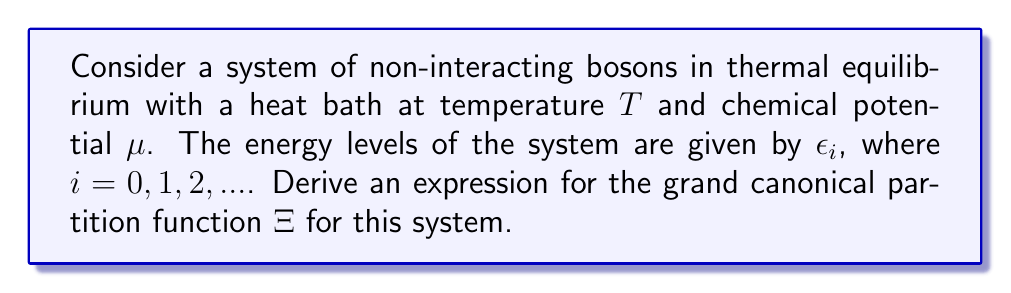Solve this math problem. Let's approach this step-by-step:

1) The grand canonical partition function $\Xi$ is defined as:

   $$\Xi = \sum_{\{n_i\}} e^{-\beta(E - \mu N)}$$

   where $\beta = \frac{1}{k_B T}$, $E$ is the total energy, and $N$ is the total number of particles.

2) For a system of non-interacting particles, we can write:

   $$E = \sum_i n_i \epsilon_i$$
   $$N = \sum_i n_i$$

3) Substituting these into the partition function:

   $$\Xi = \sum_{\{n_i\}} \exp\left(-\beta\sum_i n_i \epsilon_i + \beta\mu\sum_i n_i\right)$$

4) This can be rewritten as:

   $$\Xi = \sum_{\{n_i\}} \prod_i \exp\left[-\beta n_i (\epsilon_i - \mu)\right]$$

5) For bosons, each $n_i$ can take any non-negative integer value. Therefore, we can separate the sum over all configurations into a product of sums for each energy level:

   $$\Xi = \prod_i \sum_{n_i=0}^{\infty} \exp\left[-\beta n_i (\epsilon_i - \mu)\right]$$

6) The sum in this expression is a geometric series with first term 1 and ratio $\exp[-\beta(\epsilon_i - \mu)]$. The sum of this infinite geometric series is:

   $$\sum_{n_i=0}^{\infty} \exp\left[-\beta n_i (\epsilon_i - \mu)\right] = \frac{1}{1 - \exp[-\beta(\epsilon_i - \mu)]}$$

7) Therefore, the final expression for the grand canonical partition function is:

   $$\Xi = \prod_i \frac{1}{1 - \exp[-\beta(\epsilon_i - \mu)]}$$

This result is valid for $\mu < \epsilon_0$, where $\epsilon_0$ is the ground state energy, to ensure convergence.
Answer: $$\Xi = \prod_i \frac{1}{1 - e^{-\beta(\epsilon_i - \mu)}}$$ 